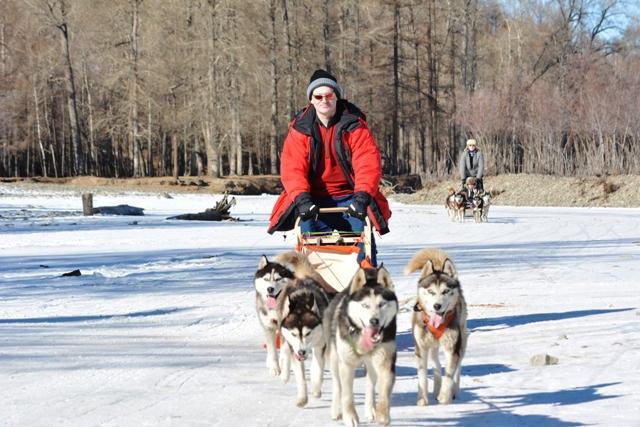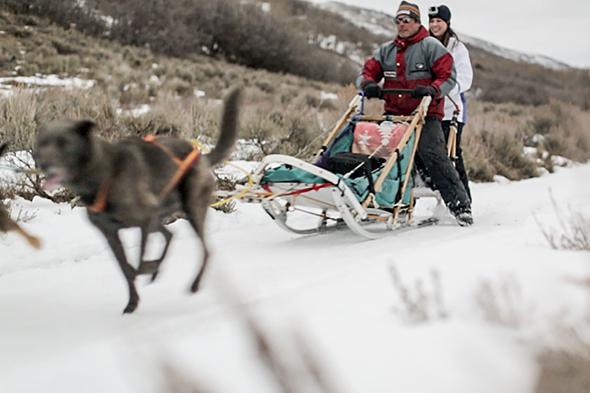The first image is the image on the left, the second image is the image on the right. Considering the images on both sides, is "One image in the pair shows multiple dog sleds and the other shows a single dog sled with multiple people riding." valid? Answer yes or no. Yes. The first image is the image on the left, the second image is the image on the right. Examine the images to the left and right. Is the description "At least two dogs are in the foreground leading a dog sled in each image, and each image shows a dog team heading toward the camera." accurate? Answer yes or no. No. 